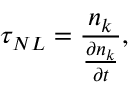<formula> <loc_0><loc_0><loc_500><loc_500>\tau _ { N L } = \frac { n _ { k } } { \frac { \partial n _ { k } } { \partial t } } ,</formula> 